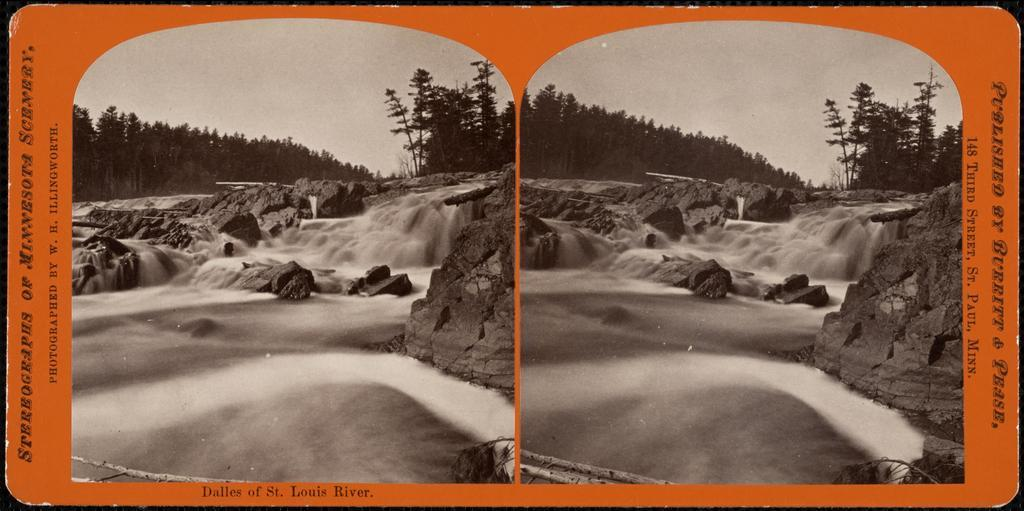What is depicted as a replica in the image? There is a replica of a poster in the image. What type of natural environment is visible in the image? There are trees and a waterfall in the image, which suggests a natural setting. What is visible in the sky in the image? The sky is visible in the image. What type of geological feature is present in the image? There is a rock in the image. What can be read or seen in written form in the image? Text is visible in the image. What type of fang can be seen hanging from the rock in the image? There is no fang present in the image; it features a replica of a poster, trees, a waterfall, the sky, and text. Is there a chain visible connecting the poster replica to the rock in the image? There is no chain visible connecting the poster replica to the rock in the image. 